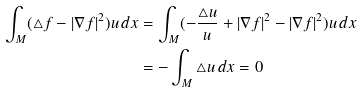<formula> <loc_0><loc_0><loc_500><loc_500>\int _ { M } ( \triangle f - | \nabla f | ^ { 2 } ) u \, d x & = \int _ { M } ( - \frac { \triangle u } { u } + | \nabla f | ^ { 2 } - | \nabla f | ^ { 2 } ) u \, d x \\ & = - \int _ { M } \triangle u \, d x = 0</formula> 